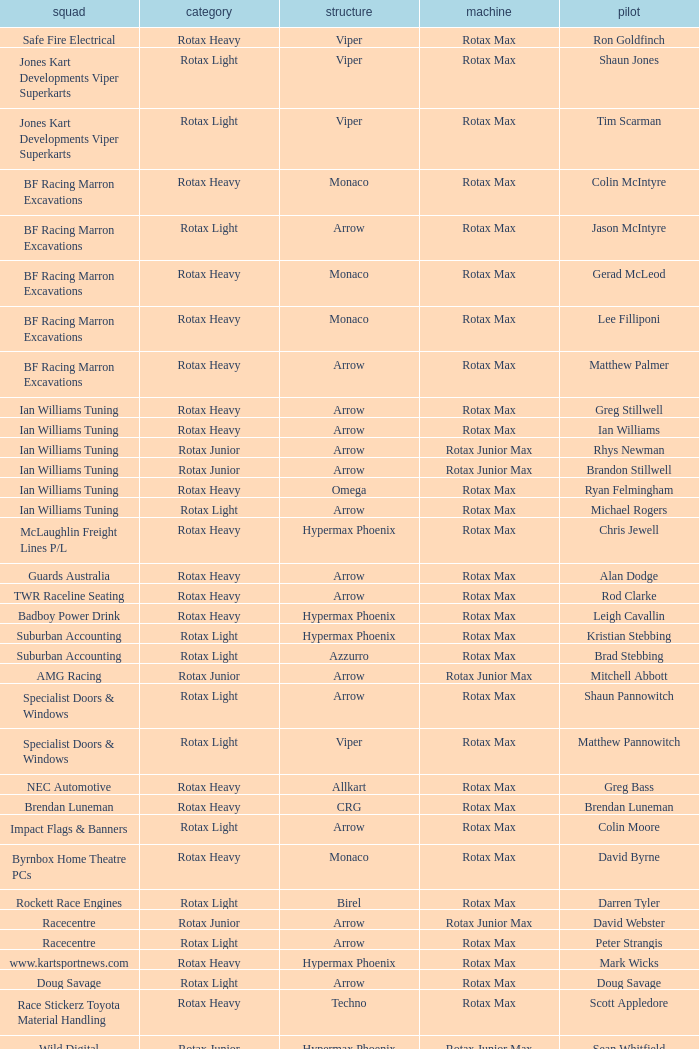Which team does Colin Moore drive for? Impact Flags & Banners. 